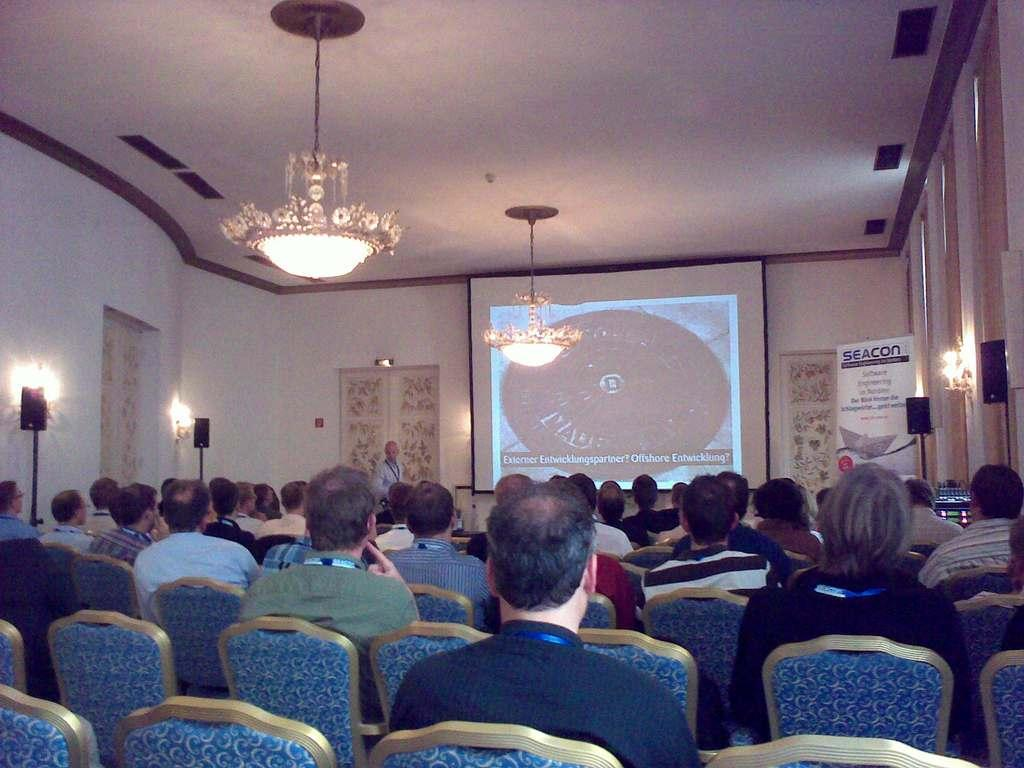How many people are in the image? There is a group of people in the image. What are some of the people in the image doing? Some people are sitting on chairs, and one person is standing. What can be seen in the background of the image? There is a screen and lights in the background of the image. What level of discussion is taking place among the people in the image? There is no indication of a discussion or its level in the image. Can you see any teeth in the image? There is no reference to teeth or any dental-related activity in the image. 